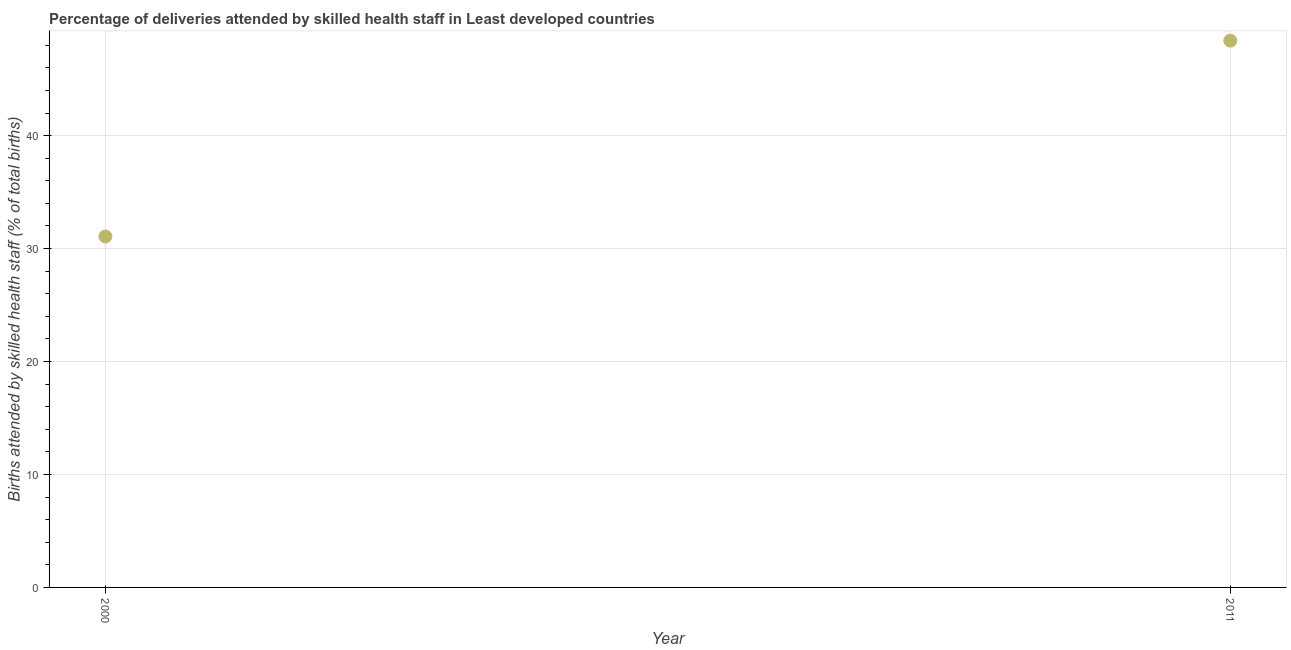What is the number of births attended by skilled health staff in 2011?
Ensure brevity in your answer.  48.41. Across all years, what is the maximum number of births attended by skilled health staff?
Make the answer very short. 48.41. Across all years, what is the minimum number of births attended by skilled health staff?
Offer a terse response. 31.07. What is the sum of the number of births attended by skilled health staff?
Ensure brevity in your answer.  79.48. What is the difference between the number of births attended by skilled health staff in 2000 and 2011?
Your answer should be compact. -17.34. What is the average number of births attended by skilled health staff per year?
Give a very brief answer. 39.74. What is the median number of births attended by skilled health staff?
Your answer should be compact. 39.74. Do a majority of the years between 2000 and 2011 (inclusive) have number of births attended by skilled health staff greater than 18 %?
Your answer should be compact. Yes. What is the ratio of the number of births attended by skilled health staff in 2000 to that in 2011?
Ensure brevity in your answer.  0.64. In how many years, is the number of births attended by skilled health staff greater than the average number of births attended by skilled health staff taken over all years?
Your response must be concise. 1. How many dotlines are there?
Keep it short and to the point. 1. What is the difference between two consecutive major ticks on the Y-axis?
Give a very brief answer. 10. Does the graph contain any zero values?
Provide a succinct answer. No. Does the graph contain grids?
Your answer should be very brief. Yes. What is the title of the graph?
Offer a terse response. Percentage of deliveries attended by skilled health staff in Least developed countries. What is the label or title of the Y-axis?
Offer a terse response. Births attended by skilled health staff (% of total births). What is the Births attended by skilled health staff (% of total births) in 2000?
Your response must be concise. 31.07. What is the Births attended by skilled health staff (% of total births) in 2011?
Your response must be concise. 48.41. What is the difference between the Births attended by skilled health staff (% of total births) in 2000 and 2011?
Your answer should be compact. -17.34. What is the ratio of the Births attended by skilled health staff (% of total births) in 2000 to that in 2011?
Provide a short and direct response. 0.64. 